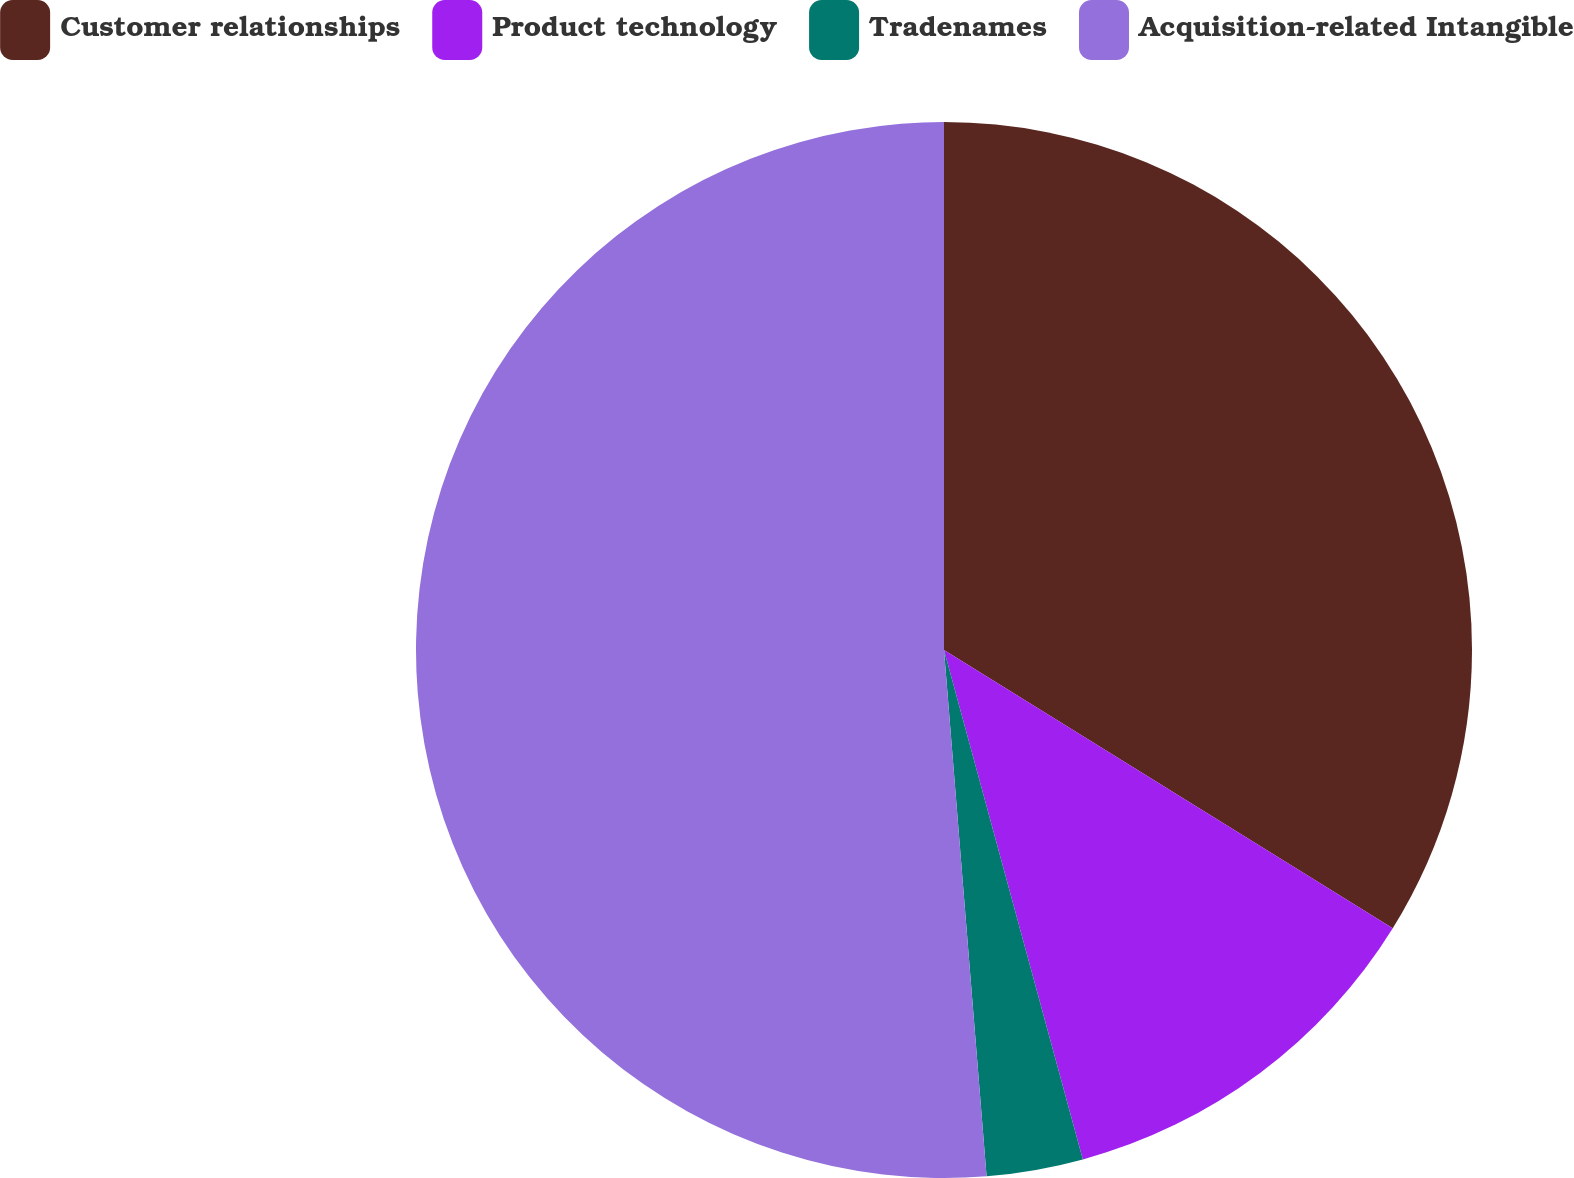<chart> <loc_0><loc_0><loc_500><loc_500><pie_chart><fcel>Customer relationships<fcel>Product technology<fcel>Tradenames<fcel>Acquisition-related Intangible<nl><fcel>33.83%<fcel>11.93%<fcel>2.95%<fcel>51.28%<nl></chart> 